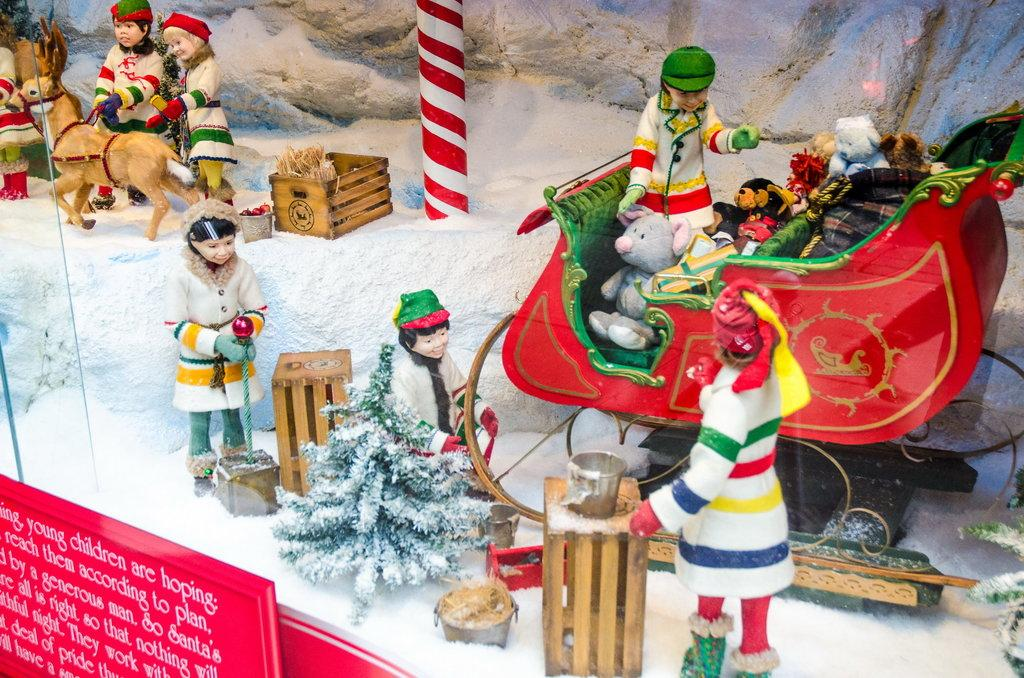What can be seen in abundance in the image? There are many toys in the image. What other object is present in the image besides the toys? There is a display board in the image. What is featured on the display board? There is text written on the display board. Are there any plants growing on the display board in the image? There are no plants visible on the display board in the image. Is the display board being used to demonstrate a coil in the image? There is no coil present in the image, and the display board does not appear to be demonstrating any such object. 